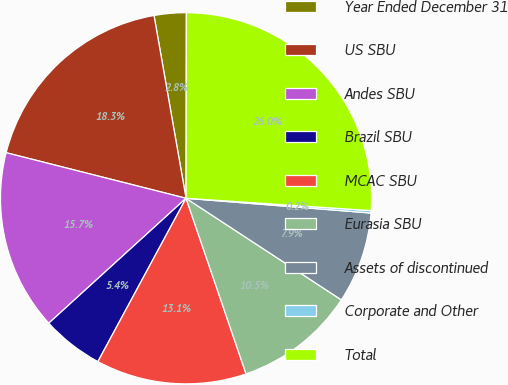Convert chart. <chart><loc_0><loc_0><loc_500><loc_500><pie_chart><fcel>Year Ended December 31<fcel>US SBU<fcel>Andes SBU<fcel>Brazil SBU<fcel>MCAC SBU<fcel>Eurasia SBU<fcel>Assets of discontinued<fcel>Corporate and Other<fcel>Total<nl><fcel>2.79%<fcel>18.29%<fcel>15.7%<fcel>5.37%<fcel>13.12%<fcel>10.54%<fcel>7.95%<fcel>0.21%<fcel>26.03%<nl></chart> 